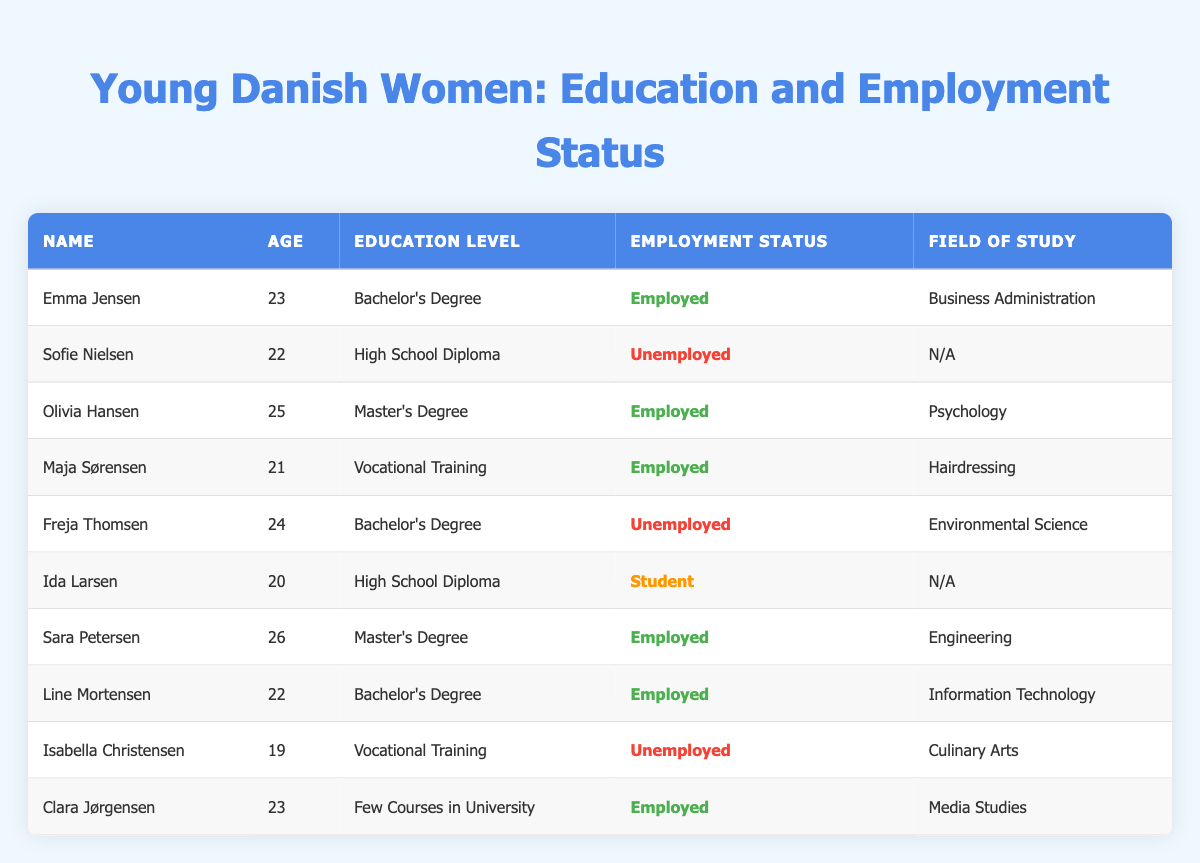What is the education level of Emma Jensen? Emma Jensen is listed in the table and her Education Level can be found in the corresponding cell. It states "Bachelor's Degree".
Answer: Bachelor's Degree How many young women are employed? To find the number of employed young women, I will count the rows where the Employment Status is marked as "Employed". There are five such entries: Emma Jensen, Olivia Hansen, Maja Sørensen, Sara Petersen, and Line Mortensen.
Answer: 5 Are there any women under 21 years old who are employed? First, I need to filter the table for women under 21 years of age. The only two young women are Ida Larsen (20) and Isabella Christensen (19), both of whom are either students or unemployed. Therefore, none of the employed women meet this criterion.
Answer: No What is the average age of young women with a Bachelor's Degree? There are three women with a Bachelor's Degree: Emma Jensen (23), Freja Thomsen (24), and Line Mortensen (22). The ages sum to 69 (23 + 24 + 22 = 69), and when divided by the number of women (3), the average age is 69/3 = 23.
Answer: 23 Is it true that all women with a Master's Degree are employed? There are two women with a Master's Degree: Olivia Hansen and Sara Petersen. Both of their Employment Statuses are marked as "Employed". Therefore, it is true.
Answer: Yes Which field of study has the most employed individuals? I will look for the fields of study of the employed women in the table. The fields are Business Administration, Psychology, Hairdressing, Engineering, and Information Technology, all uniquely represented. Hence, there is a tie as each employed woman has a different field of study.
Answer: There is a tie How many women with high school diplomas are currently students? There are two women listed with High School Diplomas: Sofie Nielsen (Unemployed) and Ida Larsen (Student). Only Ida Larsen is currently a student.
Answer: 1 What percentage of young women who studied Culinary Arts are unemployed? Isabella Christensen is the only woman who studied Culinary Arts and is listed as unemployed. To calculate the percentage, I take the number of unemployed women with Culinary Arts (1) divided by the total number of women in this field (1), which equals 100%.
Answer: 100% 